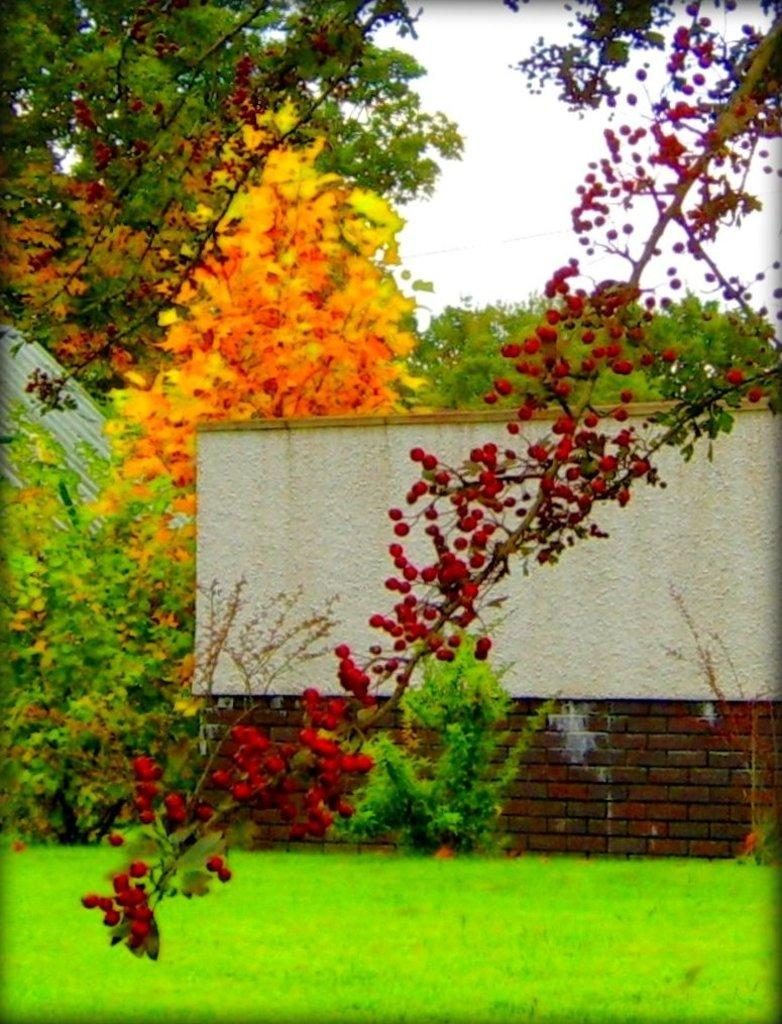What type of fruit can be seen on the tree in the image? There are berries on the branches of a tree in the image. What type of vegetation is on the ground in the image? There is grass on the ground in the image. What other types of plants are visible in the image? There are plants in the image. What is the background of the image composed of? There is a wall and trees in the background of the image, and the sky is also visible. What type of window can be seen in the image? There is no window present in the image. What can the berries be used for in the image? The berries are on the tree and not being used for anything in the image. 